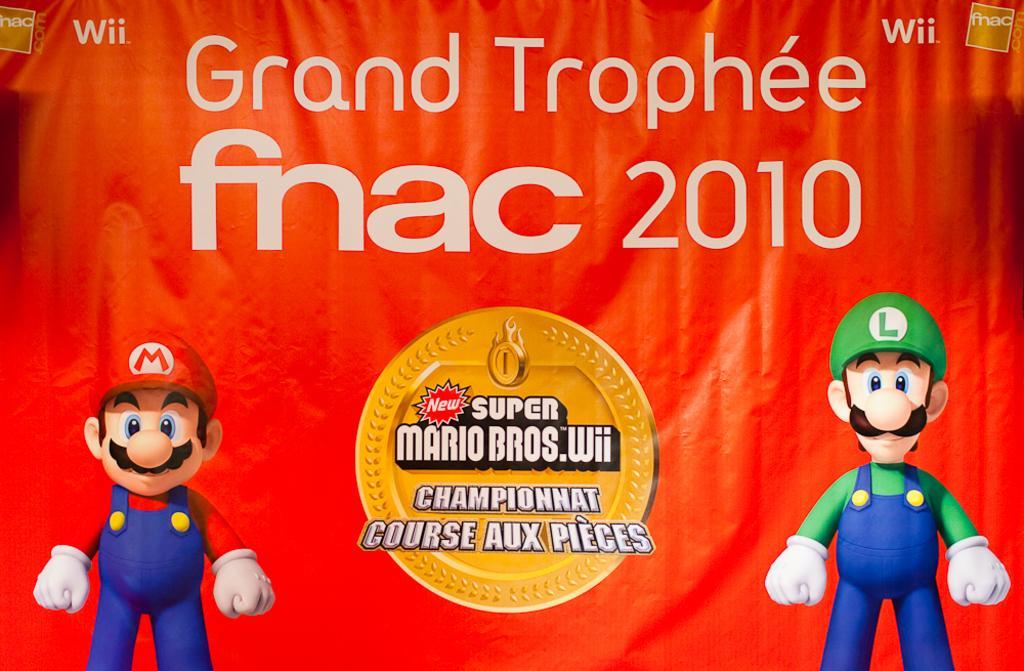Describe this image in one or two sentences. This picture is a banner. In the center of the image we can see a text and logo are present. On the left and right side of the image cartoons are there. 